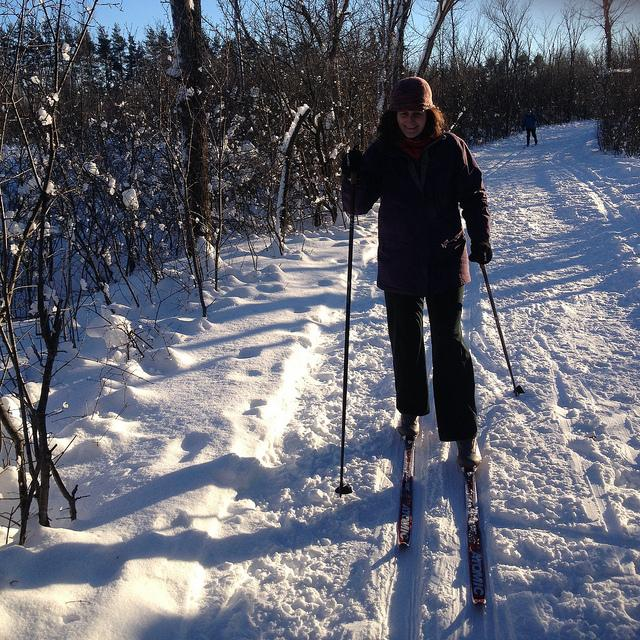What is making the thin lines in the snow?

Choices:
A) snakes
B) birds
C) tires
D) skis skis 